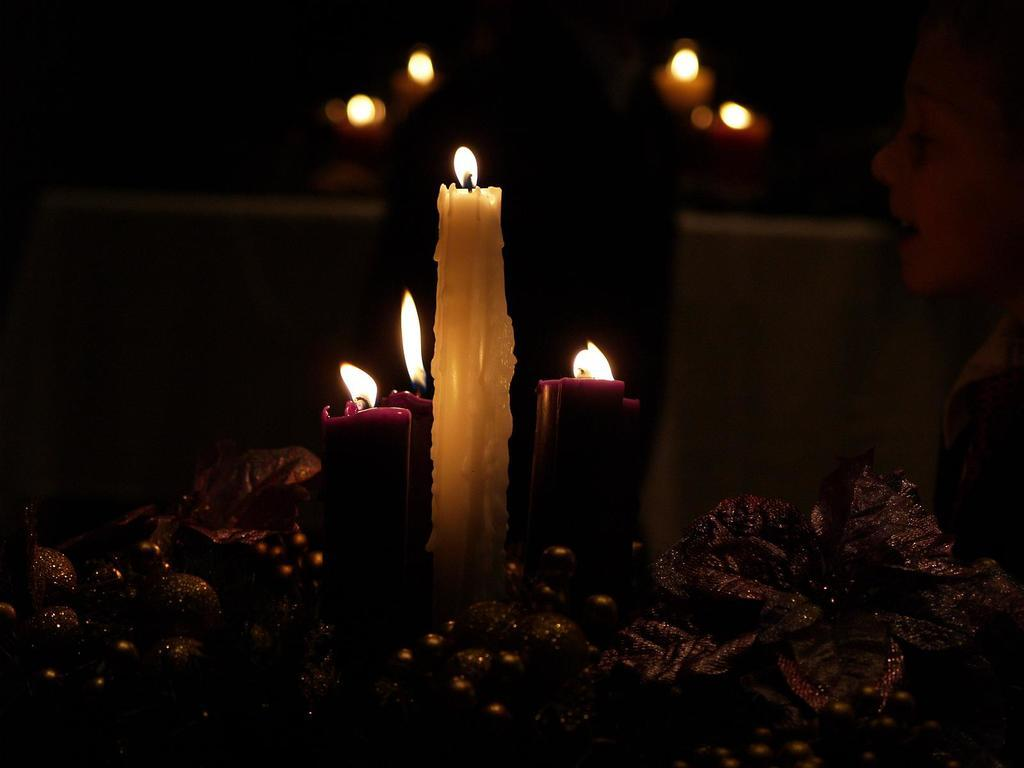What is happening with the candles in the image? The candles are lighted in the image. What can be seen at the bottom of the image? There are decorative items at the bottom of the image. Where is the kid located in the image? The kid is on the right side of the image. Can you describe the person behind the decorative items? There is a person behind the decorative items. What type of ship can be seen sailing in the waves in the image? There is no ship or waves present in the image; it features candles, decorative items, a kid, and a person. 